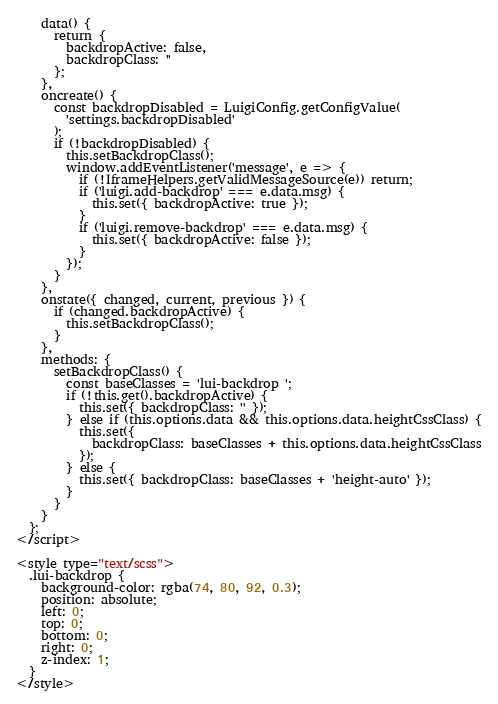Convert code to text. <code><loc_0><loc_0><loc_500><loc_500><_HTML_>    data() {
      return {
        backdropActive: false,
        backdropClass: ''
      };
    },
    oncreate() {
      const backdropDisabled = LuigiConfig.getConfigValue(
        'settings.backdropDisabled'
      );
      if (!backdropDisabled) {
        this.setBackdropClass();
        window.addEventListener('message', e => {
          if (!IframeHelpers.getValidMessageSource(e)) return;
          if ('luigi.add-backdrop' === e.data.msg) {
            this.set({ backdropActive: true });
          }
          if ('luigi.remove-backdrop' === e.data.msg) {
            this.set({ backdropActive: false });
          }
        });
      }
    },
    onstate({ changed, current, previous }) {
      if (changed.backdropActive) {
        this.setBackdropClass();
      }
    },
    methods: {
      setBackdropClass() {
        const baseClasses = 'lui-backdrop ';
        if (!this.get().backdropActive) {
          this.set({ backdropClass: '' });
        } else if (this.options.data && this.options.data.heightCssClass) {
          this.set({
            backdropClass: baseClasses + this.options.data.heightCssClass
          });
        } else {
          this.set({ backdropClass: baseClasses + 'height-auto' });
        }
      }
    }
  };
</script>

<style type="text/scss">
  .lui-backdrop {
    background-color: rgba(74, 80, 92, 0.3);
    position: absolute;
    left: 0;
    top: 0;
    bottom: 0;
    right: 0;
    z-index: 1;
  }
</style>
</code> 